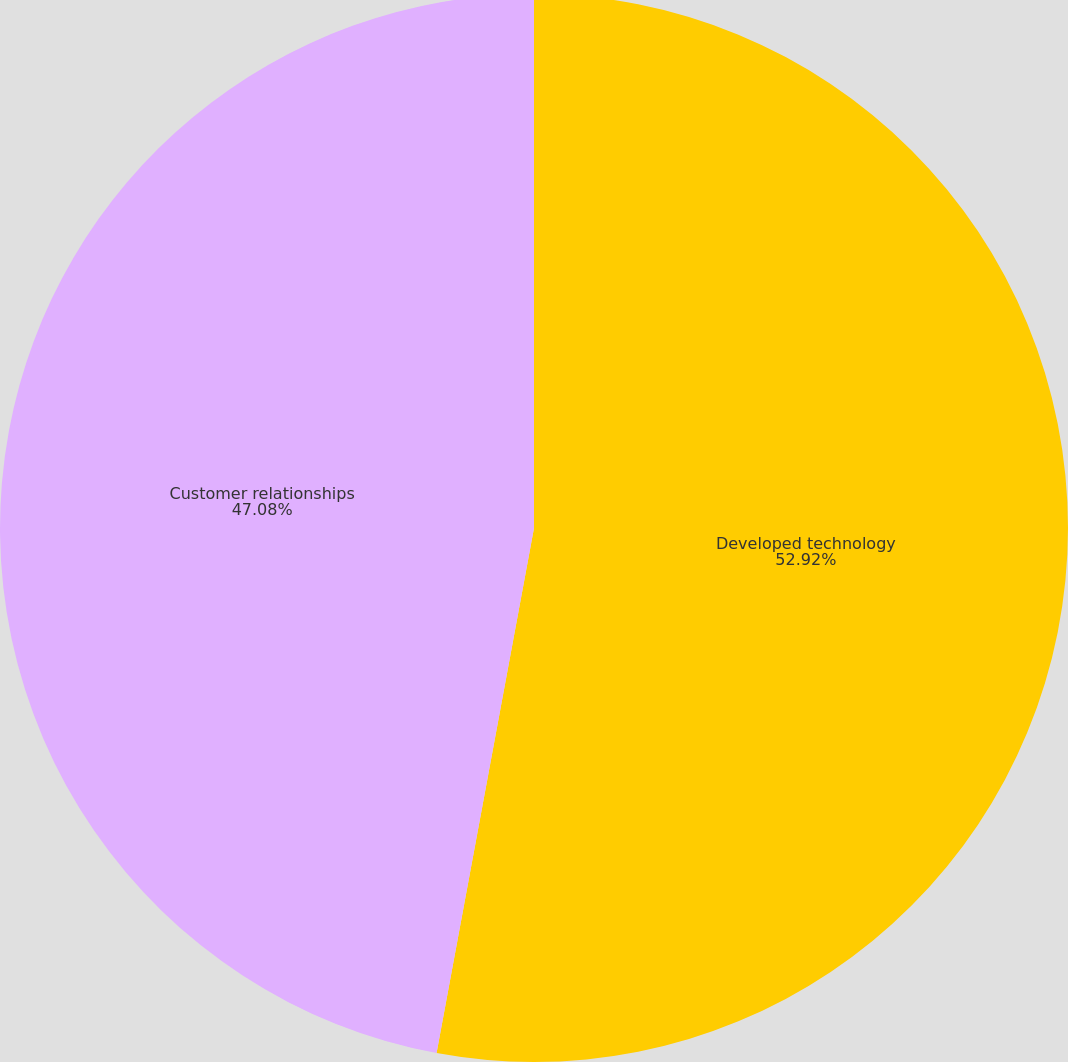Convert chart to OTSL. <chart><loc_0><loc_0><loc_500><loc_500><pie_chart><fcel>Developed technology<fcel>Customer relationships<nl><fcel>52.92%<fcel>47.08%<nl></chart> 